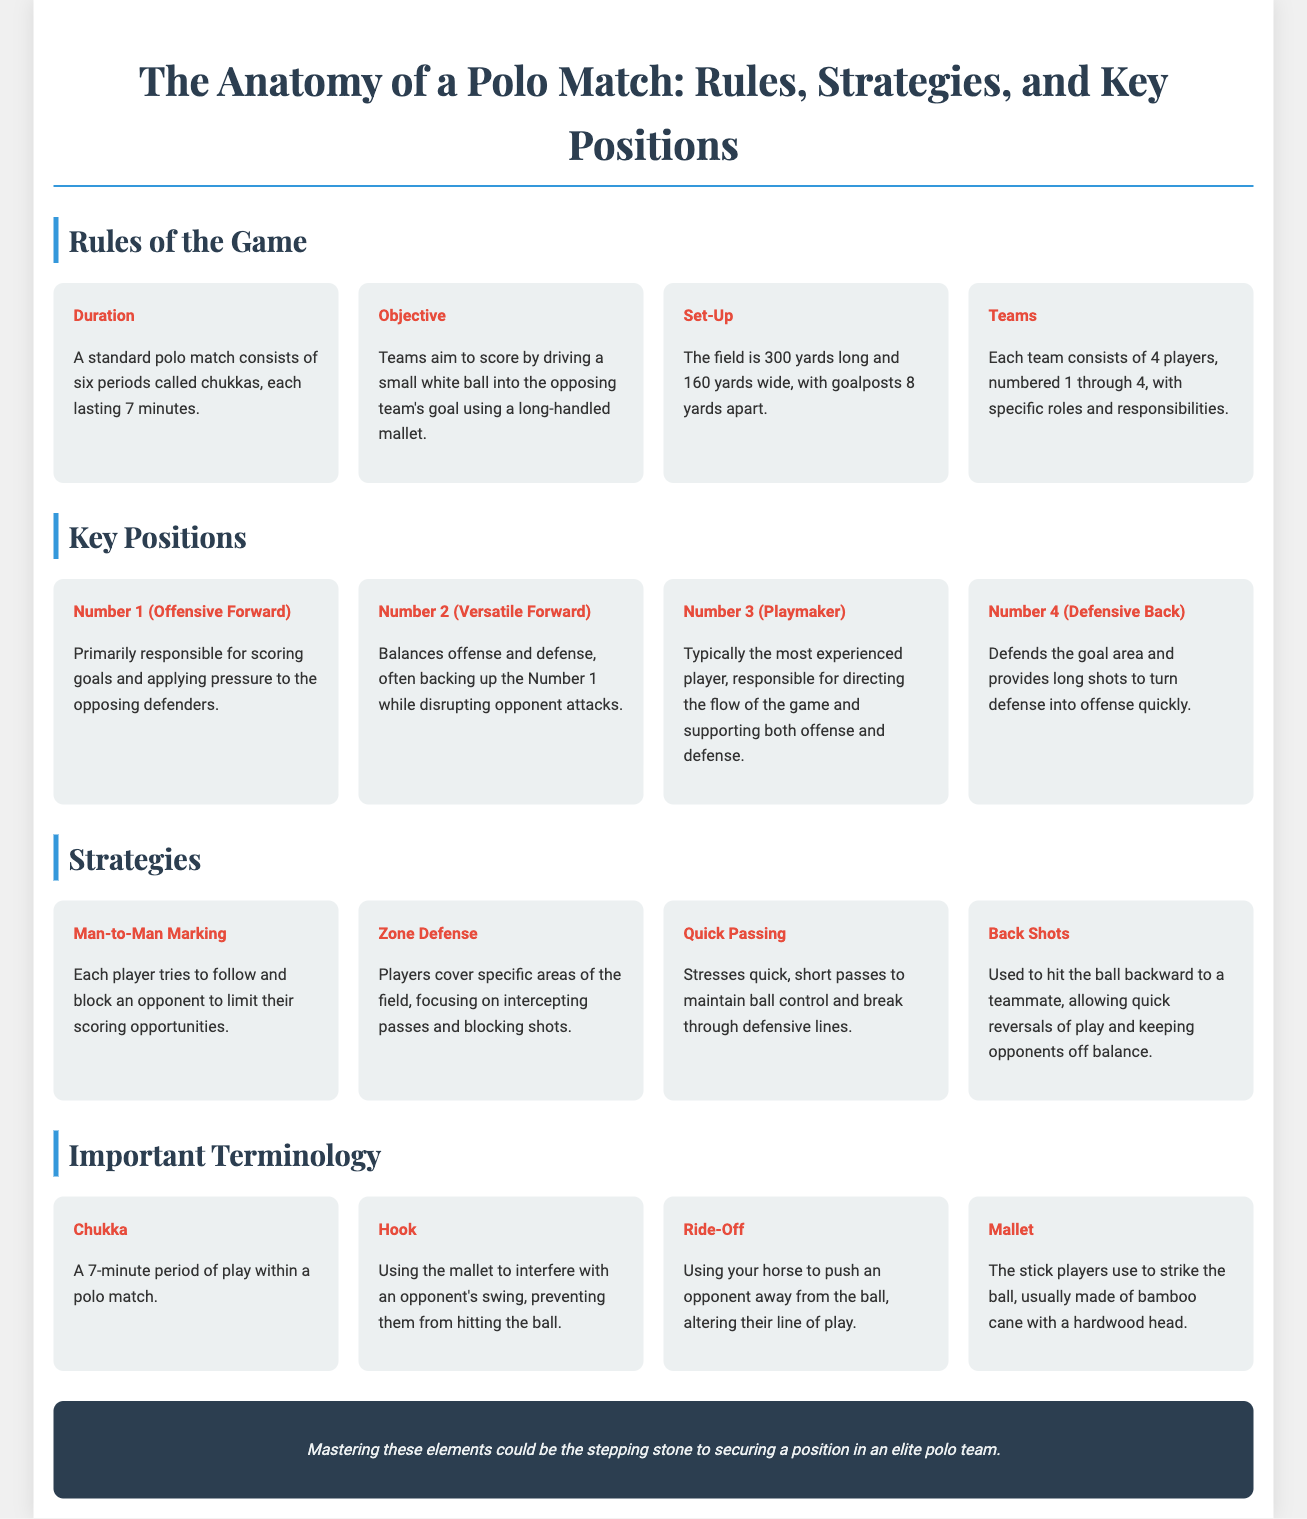what is the duration of each chukka? A standard polo match consists of six periods called chukkas, each lasting 7 minutes.
Answer: 7 minutes how many players are in each polo team? Each team consists of 4 players, numbered 1 through 4, with specific roles and responsibilities.
Answer: 4 players what is the primary responsibility of Number 1? Primarily responsible for scoring goals and applying pressure to the opposing defenders.
Answer: scoring goals what does zone defense focus on? Players cover specific areas of the field, focusing on intercepting passes and blocking shots.
Answer: intercepting passes what happens during a ride-off? Using your horse to push an opponent away from the ball, altering their line of play.
Answer: push an opponent away which strategy emphasizes quick, short passes? Stresses quick, short passes to maintain ball control and break through defensive lines.
Answer: Quick Passing what is the width of a polo field? The field is 300 yards long and 160 yards wide, with goalposts 8 yards apart.
Answer: 160 yards who is the playmaker in a polo team? Typically the most experienced player, responsible for directing the flow of the game and supporting both offense and defense.
Answer: Number 3 what is the purpose of a mallet? The stick players use to strike the ball, usually made of bamboo cane with a hardwood head.
Answer: strike the ball 